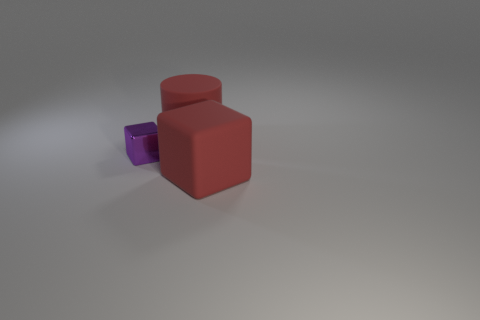Are there any other things that are the same material as the large red cylinder?
Your response must be concise. Yes. There is a large rubber thing behind the cube in front of the metal object; are there any big red rubber cubes right of it?
Offer a terse response. Yes. How many big things are either green spheres or matte blocks?
Your answer should be very brief. 1. Is there any other thing that has the same color as the large cylinder?
Your response must be concise. Yes. Do the red thing that is in front of the red cylinder and the purple block have the same size?
Give a very brief answer. No. The rubber cylinder that is to the right of the shiny object on the left side of the big thing in front of the small purple shiny thing is what color?
Your response must be concise. Red. What color is the rubber block?
Offer a terse response. Red. Do the cylinder and the tiny object have the same color?
Keep it short and to the point. No. Are the large red object that is in front of the purple block and the big thing that is behind the purple thing made of the same material?
Your response must be concise. Yes. There is a red thing that is the same shape as the purple shiny thing; what material is it?
Provide a short and direct response. Rubber. 